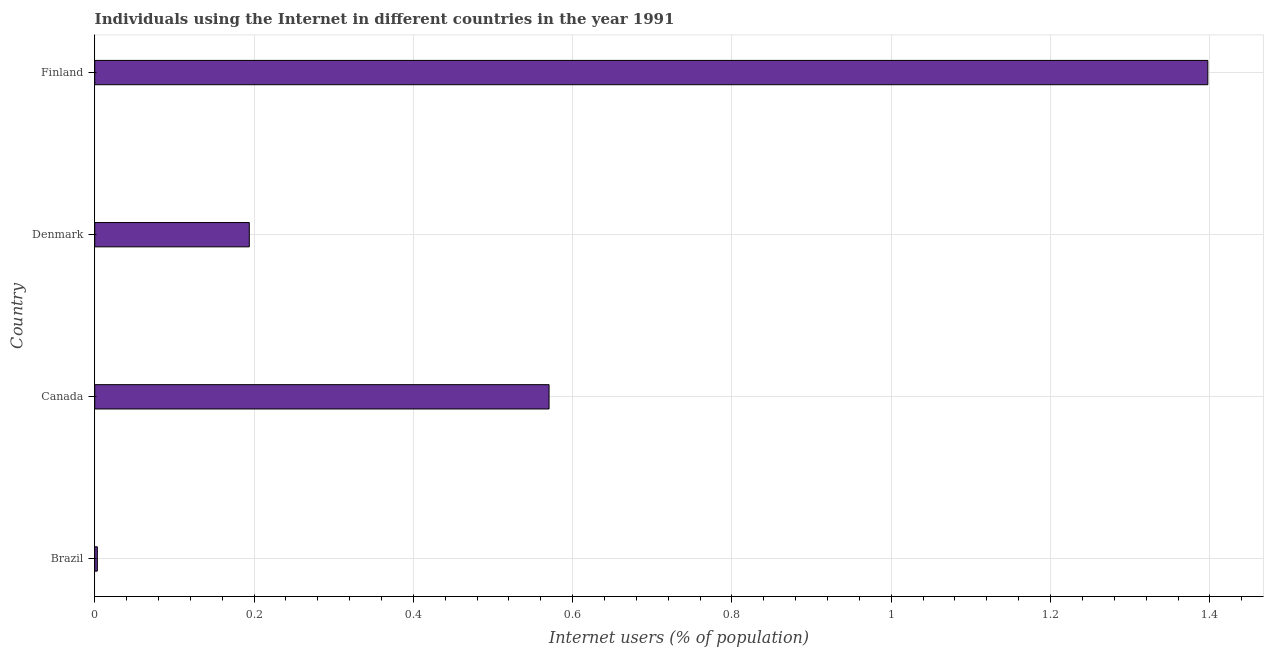Does the graph contain grids?
Provide a succinct answer. Yes. What is the title of the graph?
Your answer should be very brief. Individuals using the Internet in different countries in the year 1991. What is the label or title of the X-axis?
Offer a terse response. Internet users (% of population). What is the label or title of the Y-axis?
Make the answer very short. Country. What is the number of internet users in Brazil?
Ensure brevity in your answer.  0. Across all countries, what is the maximum number of internet users?
Make the answer very short. 1.4. Across all countries, what is the minimum number of internet users?
Make the answer very short. 0. In which country was the number of internet users maximum?
Ensure brevity in your answer.  Finland. In which country was the number of internet users minimum?
Your answer should be very brief. Brazil. What is the sum of the number of internet users?
Provide a short and direct response. 2.17. What is the difference between the number of internet users in Brazil and Finland?
Make the answer very short. -1.39. What is the average number of internet users per country?
Your answer should be very brief. 0.54. What is the median number of internet users?
Your answer should be very brief. 0.38. What is the ratio of the number of internet users in Brazil to that in Finland?
Your answer should be compact. 0. Is the number of internet users in Brazil less than that in Finland?
Your answer should be very brief. Yes. Is the difference between the number of internet users in Canada and Denmark greater than the difference between any two countries?
Your answer should be very brief. No. What is the difference between the highest and the second highest number of internet users?
Make the answer very short. 0.83. Is the sum of the number of internet users in Brazil and Canada greater than the maximum number of internet users across all countries?
Give a very brief answer. No. What is the difference between the highest and the lowest number of internet users?
Ensure brevity in your answer.  1.39. In how many countries, is the number of internet users greater than the average number of internet users taken over all countries?
Ensure brevity in your answer.  2. How many bars are there?
Provide a short and direct response. 4. Are all the bars in the graph horizontal?
Offer a terse response. Yes. What is the difference between two consecutive major ticks on the X-axis?
Keep it short and to the point. 0.2. What is the Internet users (% of population) in Brazil?
Ensure brevity in your answer.  0. What is the Internet users (% of population) in Canada?
Offer a terse response. 0.57. What is the Internet users (% of population) of Denmark?
Your answer should be very brief. 0.19. What is the Internet users (% of population) of Finland?
Your response must be concise. 1.4. What is the difference between the Internet users (% of population) in Brazil and Canada?
Offer a very short reply. -0.57. What is the difference between the Internet users (% of population) in Brazil and Denmark?
Ensure brevity in your answer.  -0.19. What is the difference between the Internet users (% of population) in Brazil and Finland?
Offer a very short reply. -1.39. What is the difference between the Internet users (% of population) in Canada and Denmark?
Keep it short and to the point. 0.38. What is the difference between the Internet users (% of population) in Canada and Finland?
Ensure brevity in your answer.  -0.83. What is the difference between the Internet users (% of population) in Denmark and Finland?
Your answer should be compact. -1.2. What is the ratio of the Internet users (% of population) in Brazil to that in Canada?
Offer a terse response. 0.01. What is the ratio of the Internet users (% of population) in Brazil to that in Denmark?
Your answer should be very brief. 0.02. What is the ratio of the Internet users (% of population) in Brazil to that in Finland?
Offer a terse response. 0. What is the ratio of the Internet users (% of population) in Canada to that in Denmark?
Ensure brevity in your answer.  2.94. What is the ratio of the Internet users (% of population) in Canada to that in Finland?
Keep it short and to the point. 0.41. What is the ratio of the Internet users (% of population) in Denmark to that in Finland?
Your answer should be compact. 0.14. 